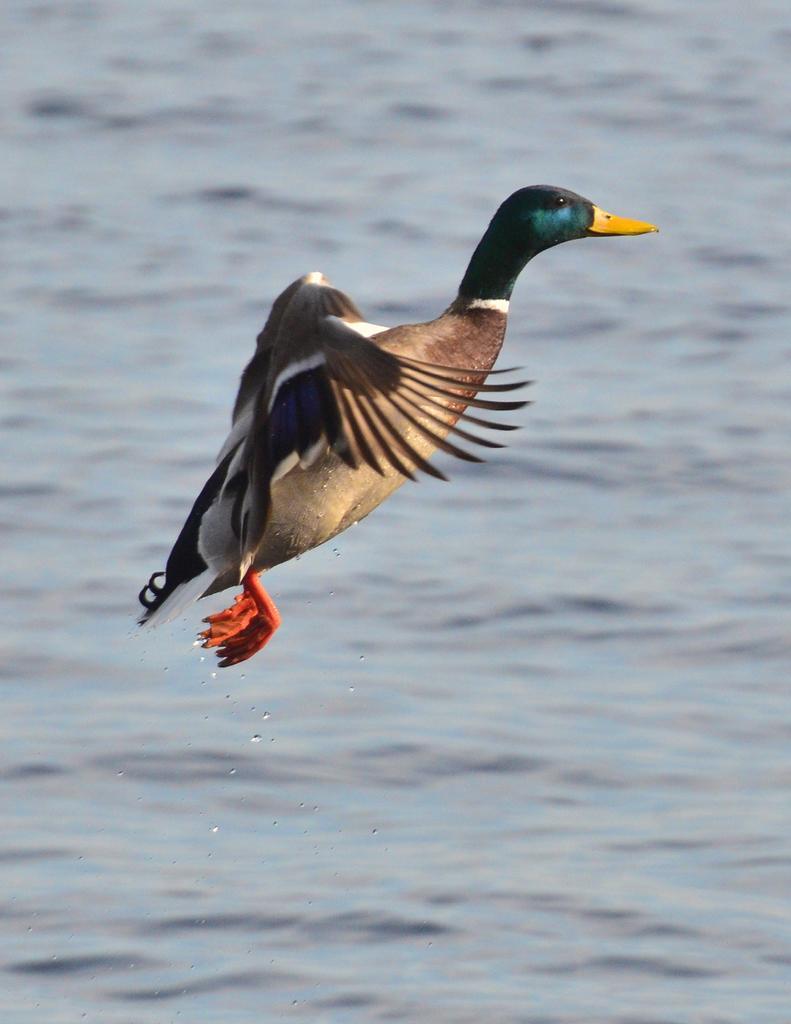Could you give a brief overview of what you see in this image? In the picture we can see a duck is flying on the water, and the duck is light brown in color and some parts, green, yellow and cream in color. 